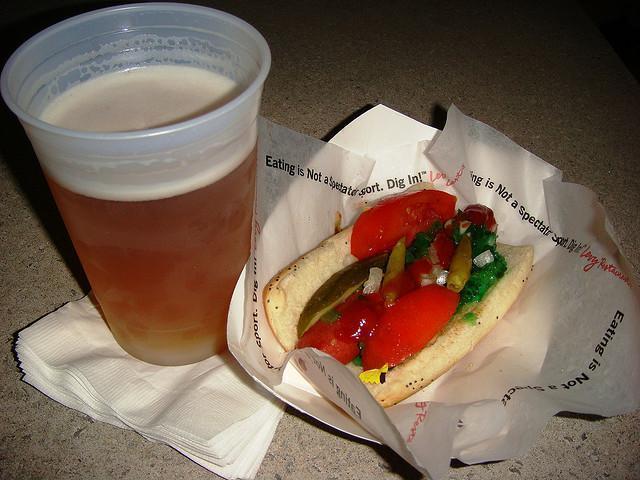What celebrity has a first name that is the same name as the red item in this tomato free sandwich?
Indicate the correct response and explain using: 'Answer: answer
Rationale: rationale.'
Options: Pepper keenan, watermelon o'gallagher, cherry smith, apple martin. Answer: pepper keenan.
Rationale: A red pepper is on a sandwich. 